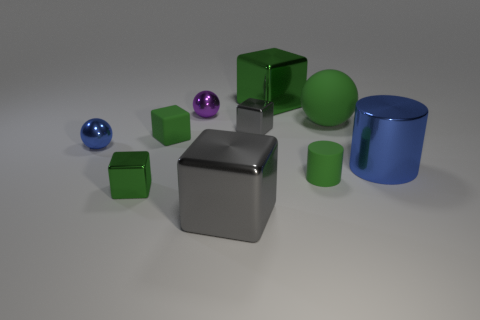Can you tell me the colors of the small spheres? Certainly! There are two small spheres, one is blue and the other is purple. 